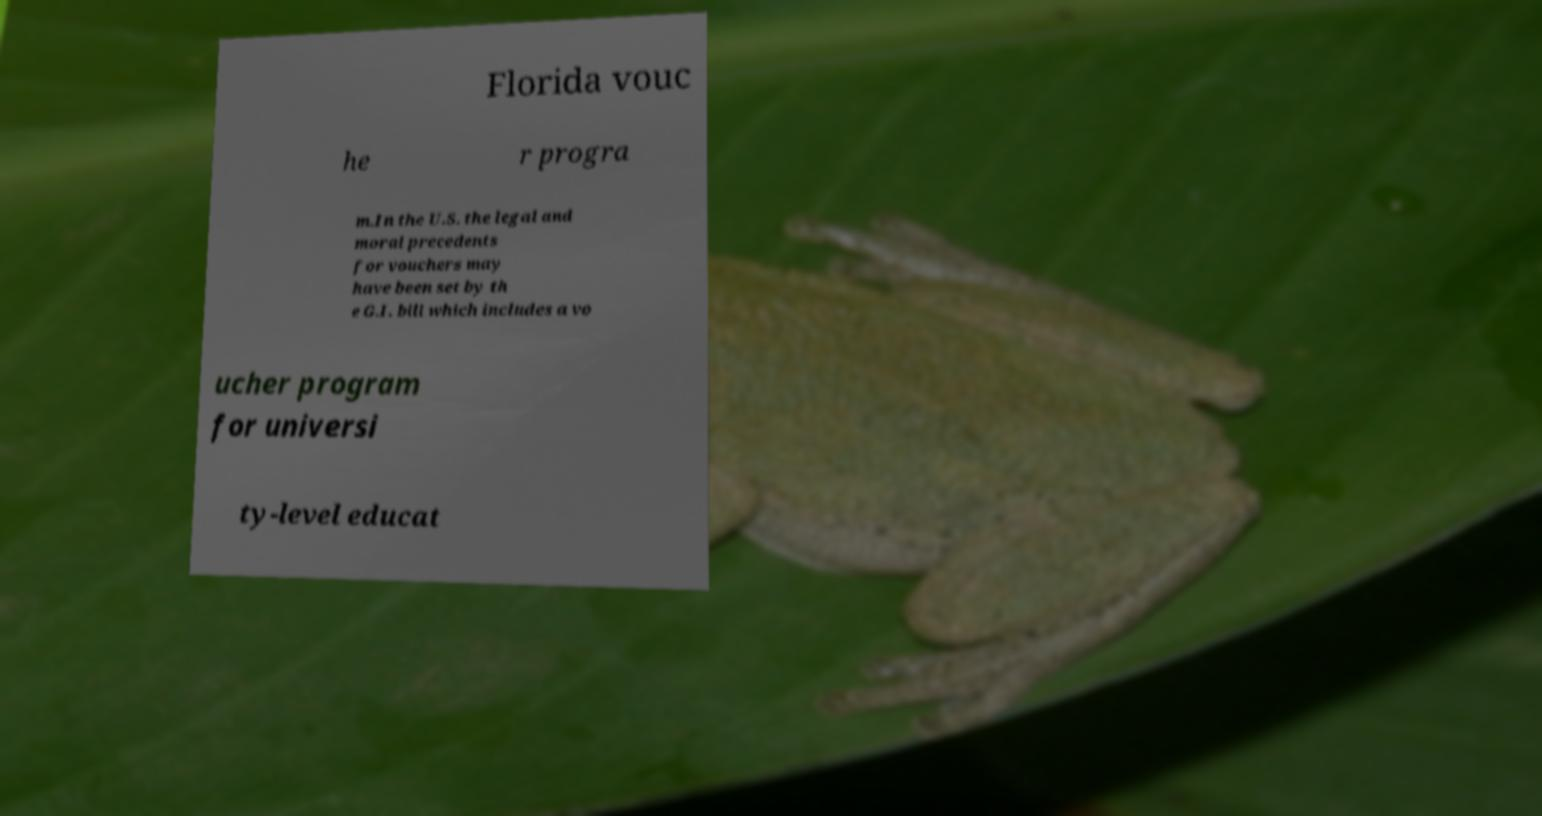I need the written content from this picture converted into text. Can you do that? Florida vouc he r progra m.In the U.S. the legal and moral precedents for vouchers may have been set by th e G.I. bill which includes a vo ucher program for universi ty-level educat 